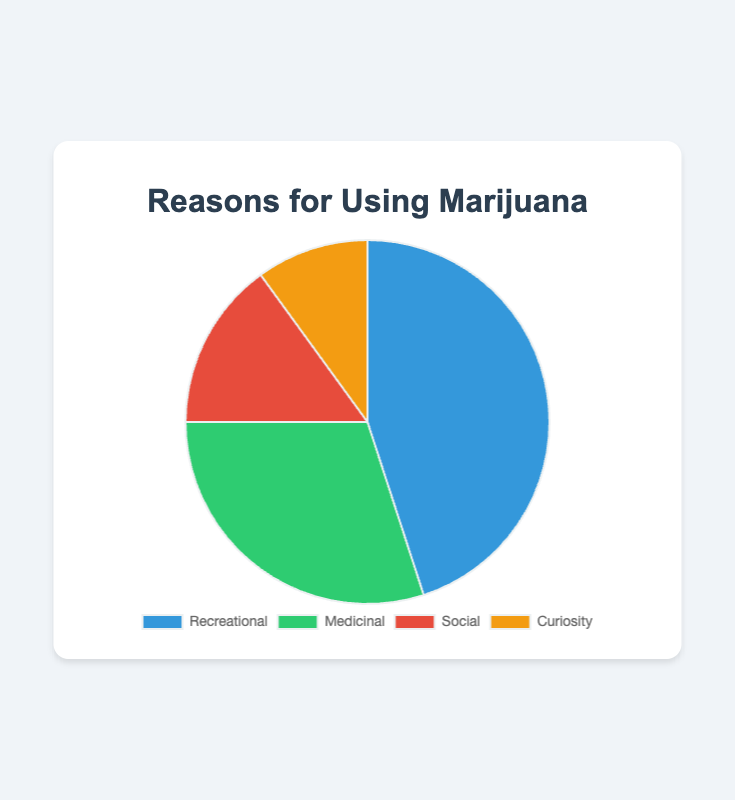Which reason is the most common for using marijuana? The pie chart shows the percentage of each reason for using marijuana. The largest segment of the pie chart represents recreational use.
Answer: Recreational use Which reason accounts for the smallest portion of marijuana use? By observing the smallest segment of the pie chart, we can see that curiosity has the smallest percentage.
Answer: Curiosity How many times more common is recreational use compared to curiosity? Recreational use is 45% and curiosity is 10%. Dividing 45 by 10 gives us the answer.
Answer: 4.5 times What is the combined percentage of social and curiosity reasons for using marijuana? Adding the percentages of social (15%) and curiosity (10%) gives us the total.
Answer: 25% How much greater is the percentage of recreational use compared to medicinal use? Subtract the medicinal use percentage (30%) from the recreational use percentage (45%).
Answer: 15% Between which two reasons is the percentage difference the smallest? The smallest difference can be found by comparing the percentages of each pair: recreational (45%), medicinal (30%), social (15%), curiosity (10%). The smallest difference is between social (15%) and curiosity (10%).
Answer: Social and Curiosity What color represents medicinal use in the pie chart? According to the legend beside the pie chart, the color for medicinal use can be identified.
Answer: Green Which reasons together make up more than half of the total reasons for using marijuana? Adding the percentages of each category: recreational (45%) and medicinal (30%), both give us a sum of 75%, which is more than half.
Answer: Recreational and Medicinal What is the average percentage for the given reasons? Sum the percentages of all reasons (45 + 30 + 15 + 10 = 100), then divide by the number of reasons (4).
Answer: 25% If the data represented 100 users, how many users use marijuana for social purposes? 15% of 100 users can be calculated by multiplying 100 by 0.15.
Answer: 15 users 